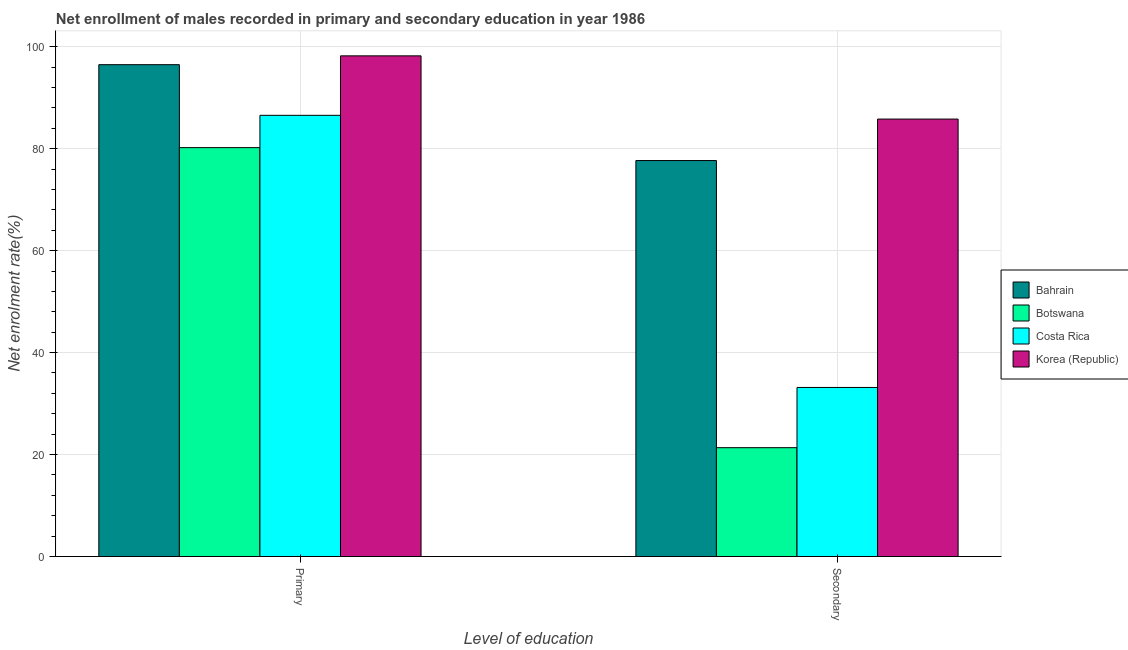How many different coloured bars are there?
Your response must be concise. 4. How many bars are there on the 2nd tick from the right?
Offer a terse response. 4. What is the label of the 1st group of bars from the left?
Make the answer very short. Primary. What is the enrollment rate in primary education in Bahrain?
Provide a short and direct response. 96.47. Across all countries, what is the maximum enrollment rate in primary education?
Offer a very short reply. 98.2. Across all countries, what is the minimum enrollment rate in primary education?
Offer a terse response. 80.2. In which country was the enrollment rate in primary education maximum?
Ensure brevity in your answer.  Korea (Republic). In which country was the enrollment rate in primary education minimum?
Your answer should be compact. Botswana. What is the total enrollment rate in primary education in the graph?
Offer a terse response. 361.39. What is the difference between the enrollment rate in primary education in Bahrain and that in Botswana?
Provide a succinct answer. 16.27. What is the difference between the enrollment rate in primary education in Bahrain and the enrollment rate in secondary education in Korea (Republic)?
Your response must be concise. 10.67. What is the average enrollment rate in secondary education per country?
Provide a short and direct response. 54.49. What is the difference between the enrollment rate in secondary education and enrollment rate in primary education in Bahrain?
Offer a terse response. -18.8. What is the ratio of the enrollment rate in primary education in Botswana to that in Bahrain?
Offer a very short reply. 0.83. In how many countries, is the enrollment rate in secondary education greater than the average enrollment rate in secondary education taken over all countries?
Offer a very short reply. 2. What does the 3rd bar from the left in Secondary represents?
Offer a terse response. Costa Rica. What does the 2nd bar from the right in Primary represents?
Keep it short and to the point. Costa Rica. How many bars are there?
Your response must be concise. 8. How many countries are there in the graph?
Give a very brief answer. 4. Are the values on the major ticks of Y-axis written in scientific E-notation?
Ensure brevity in your answer.  No. Does the graph contain any zero values?
Keep it short and to the point. No. Where does the legend appear in the graph?
Your response must be concise. Center right. What is the title of the graph?
Provide a short and direct response. Net enrollment of males recorded in primary and secondary education in year 1986. What is the label or title of the X-axis?
Ensure brevity in your answer.  Level of education. What is the label or title of the Y-axis?
Your answer should be very brief. Net enrolment rate(%). What is the Net enrolment rate(%) in Bahrain in Primary?
Ensure brevity in your answer.  96.47. What is the Net enrolment rate(%) of Botswana in Primary?
Provide a short and direct response. 80.2. What is the Net enrolment rate(%) of Costa Rica in Primary?
Offer a very short reply. 86.53. What is the Net enrolment rate(%) of Korea (Republic) in Primary?
Give a very brief answer. 98.2. What is the Net enrolment rate(%) of Bahrain in Secondary?
Your response must be concise. 77.66. What is the Net enrolment rate(%) of Botswana in Secondary?
Provide a succinct answer. 21.35. What is the Net enrolment rate(%) of Costa Rica in Secondary?
Provide a short and direct response. 33.16. What is the Net enrolment rate(%) in Korea (Republic) in Secondary?
Provide a succinct answer. 85.8. Across all Level of education, what is the maximum Net enrolment rate(%) in Bahrain?
Offer a very short reply. 96.47. Across all Level of education, what is the maximum Net enrolment rate(%) of Botswana?
Your answer should be very brief. 80.2. Across all Level of education, what is the maximum Net enrolment rate(%) in Costa Rica?
Ensure brevity in your answer.  86.53. Across all Level of education, what is the maximum Net enrolment rate(%) of Korea (Republic)?
Provide a short and direct response. 98.2. Across all Level of education, what is the minimum Net enrolment rate(%) of Bahrain?
Keep it short and to the point. 77.66. Across all Level of education, what is the minimum Net enrolment rate(%) of Botswana?
Your answer should be very brief. 21.35. Across all Level of education, what is the minimum Net enrolment rate(%) in Costa Rica?
Make the answer very short. 33.16. Across all Level of education, what is the minimum Net enrolment rate(%) in Korea (Republic)?
Provide a succinct answer. 85.8. What is the total Net enrolment rate(%) in Bahrain in the graph?
Offer a very short reply. 174.13. What is the total Net enrolment rate(%) in Botswana in the graph?
Ensure brevity in your answer.  101.54. What is the total Net enrolment rate(%) of Costa Rica in the graph?
Keep it short and to the point. 119.69. What is the total Net enrolment rate(%) in Korea (Republic) in the graph?
Offer a very short reply. 184. What is the difference between the Net enrolment rate(%) of Bahrain in Primary and that in Secondary?
Offer a terse response. 18.8. What is the difference between the Net enrolment rate(%) in Botswana in Primary and that in Secondary?
Provide a short and direct response. 58.85. What is the difference between the Net enrolment rate(%) of Costa Rica in Primary and that in Secondary?
Your answer should be compact. 53.38. What is the difference between the Net enrolment rate(%) in Korea (Republic) in Primary and that in Secondary?
Provide a short and direct response. 12.4. What is the difference between the Net enrolment rate(%) of Bahrain in Primary and the Net enrolment rate(%) of Botswana in Secondary?
Your answer should be very brief. 75.12. What is the difference between the Net enrolment rate(%) of Bahrain in Primary and the Net enrolment rate(%) of Costa Rica in Secondary?
Offer a terse response. 63.31. What is the difference between the Net enrolment rate(%) of Bahrain in Primary and the Net enrolment rate(%) of Korea (Republic) in Secondary?
Ensure brevity in your answer.  10.67. What is the difference between the Net enrolment rate(%) in Botswana in Primary and the Net enrolment rate(%) in Costa Rica in Secondary?
Your answer should be compact. 47.04. What is the difference between the Net enrolment rate(%) of Botswana in Primary and the Net enrolment rate(%) of Korea (Republic) in Secondary?
Your answer should be very brief. -5.6. What is the difference between the Net enrolment rate(%) in Costa Rica in Primary and the Net enrolment rate(%) in Korea (Republic) in Secondary?
Provide a short and direct response. 0.74. What is the average Net enrolment rate(%) in Bahrain per Level of education?
Ensure brevity in your answer.  87.06. What is the average Net enrolment rate(%) of Botswana per Level of education?
Give a very brief answer. 50.77. What is the average Net enrolment rate(%) in Costa Rica per Level of education?
Your response must be concise. 59.85. What is the average Net enrolment rate(%) in Korea (Republic) per Level of education?
Ensure brevity in your answer.  92. What is the difference between the Net enrolment rate(%) in Bahrain and Net enrolment rate(%) in Botswana in Primary?
Provide a succinct answer. 16.27. What is the difference between the Net enrolment rate(%) of Bahrain and Net enrolment rate(%) of Costa Rica in Primary?
Your response must be concise. 9.93. What is the difference between the Net enrolment rate(%) of Bahrain and Net enrolment rate(%) of Korea (Republic) in Primary?
Offer a terse response. -1.73. What is the difference between the Net enrolment rate(%) in Botswana and Net enrolment rate(%) in Costa Rica in Primary?
Provide a short and direct response. -6.34. What is the difference between the Net enrolment rate(%) in Botswana and Net enrolment rate(%) in Korea (Republic) in Primary?
Your response must be concise. -18. What is the difference between the Net enrolment rate(%) of Costa Rica and Net enrolment rate(%) of Korea (Republic) in Primary?
Your answer should be compact. -11.66. What is the difference between the Net enrolment rate(%) of Bahrain and Net enrolment rate(%) of Botswana in Secondary?
Your response must be concise. 56.32. What is the difference between the Net enrolment rate(%) in Bahrain and Net enrolment rate(%) in Costa Rica in Secondary?
Provide a short and direct response. 44.5. What is the difference between the Net enrolment rate(%) of Bahrain and Net enrolment rate(%) of Korea (Republic) in Secondary?
Provide a succinct answer. -8.14. What is the difference between the Net enrolment rate(%) in Botswana and Net enrolment rate(%) in Costa Rica in Secondary?
Ensure brevity in your answer.  -11.81. What is the difference between the Net enrolment rate(%) of Botswana and Net enrolment rate(%) of Korea (Republic) in Secondary?
Offer a very short reply. -64.45. What is the difference between the Net enrolment rate(%) of Costa Rica and Net enrolment rate(%) of Korea (Republic) in Secondary?
Ensure brevity in your answer.  -52.64. What is the ratio of the Net enrolment rate(%) of Bahrain in Primary to that in Secondary?
Offer a terse response. 1.24. What is the ratio of the Net enrolment rate(%) of Botswana in Primary to that in Secondary?
Your response must be concise. 3.76. What is the ratio of the Net enrolment rate(%) in Costa Rica in Primary to that in Secondary?
Keep it short and to the point. 2.61. What is the ratio of the Net enrolment rate(%) in Korea (Republic) in Primary to that in Secondary?
Your answer should be very brief. 1.14. What is the difference between the highest and the second highest Net enrolment rate(%) in Bahrain?
Ensure brevity in your answer.  18.8. What is the difference between the highest and the second highest Net enrolment rate(%) in Botswana?
Offer a very short reply. 58.85. What is the difference between the highest and the second highest Net enrolment rate(%) of Costa Rica?
Make the answer very short. 53.38. What is the difference between the highest and the second highest Net enrolment rate(%) in Korea (Republic)?
Provide a succinct answer. 12.4. What is the difference between the highest and the lowest Net enrolment rate(%) in Bahrain?
Provide a succinct answer. 18.8. What is the difference between the highest and the lowest Net enrolment rate(%) of Botswana?
Give a very brief answer. 58.85. What is the difference between the highest and the lowest Net enrolment rate(%) of Costa Rica?
Your answer should be very brief. 53.38. What is the difference between the highest and the lowest Net enrolment rate(%) in Korea (Republic)?
Provide a succinct answer. 12.4. 